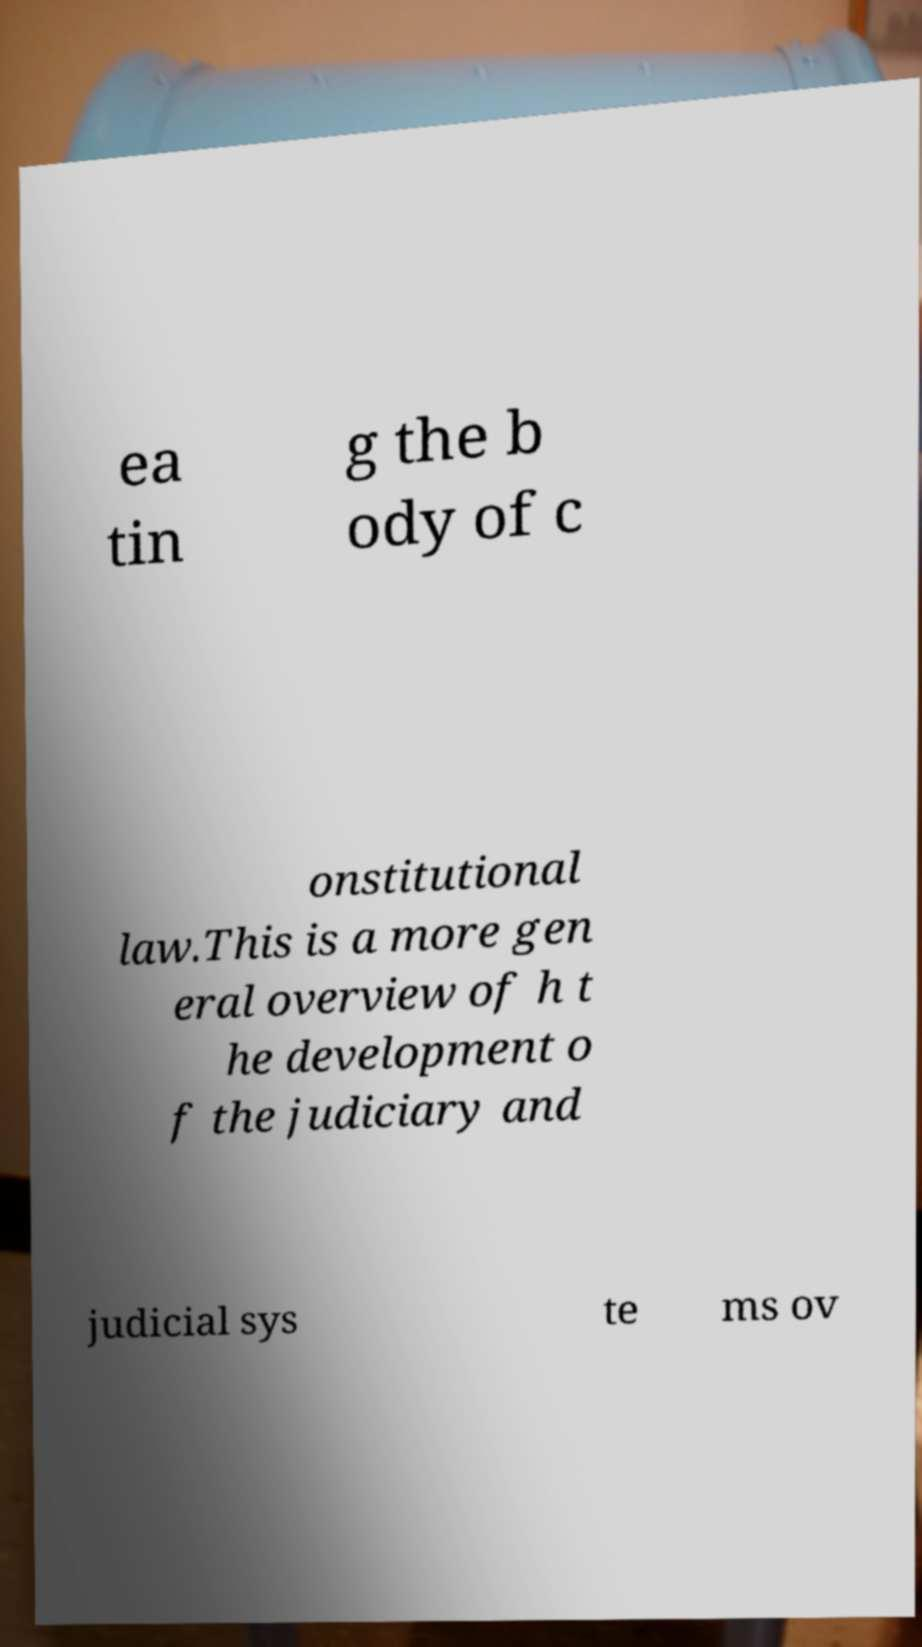Could you extract and type out the text from this image? ea tin g the b ody of c onstitutional law.This is a more gen eral overview of h t he development o f the judiciary and judicial sys te ms ov 